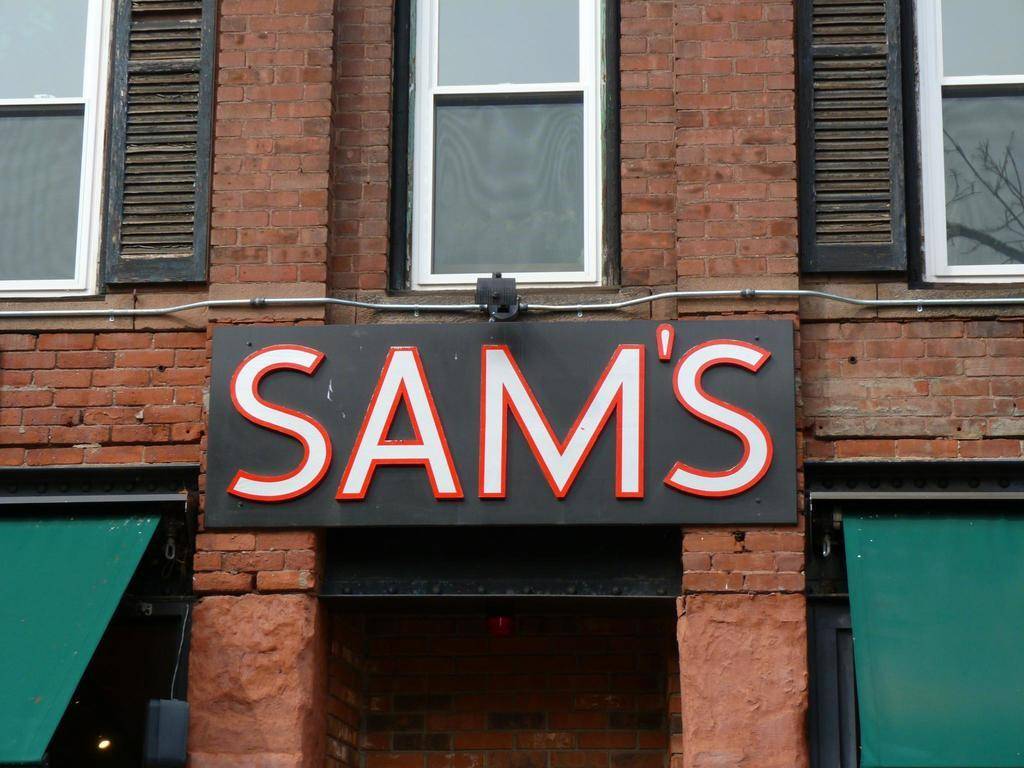<image>
Create a compact narrative representing the image presented. A sign above the door on a brick building says Sams. 